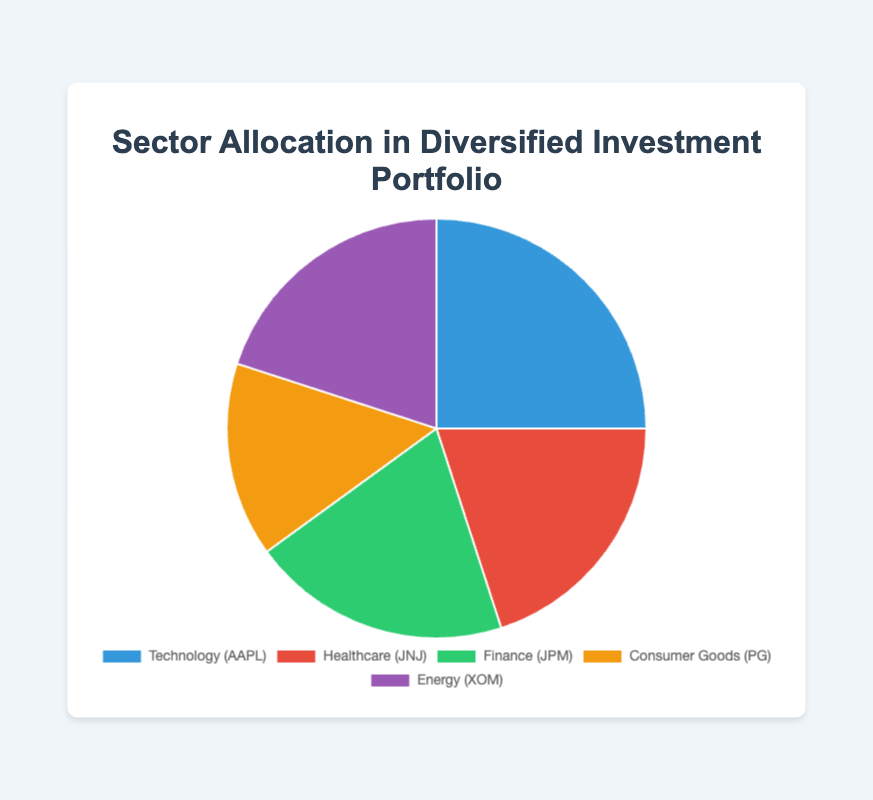What percentage of the portfolio is allocated to the Finance sector? The Finance sector, represented by JPMorgan Chase & Co. with the symbol JPM, has an allocation percentage listed in the data.
Answer: 20% Which sector has the smallest allocation in the portfolio? By comparing the allocation percentages, the Consumer Goods sector, represented by Procter & Gamble Co. with 15%, has the smallest allocation.
Answer: Consumer Goods What is the combined allocation percentage for the Technology and Healthcare sectors? The Technology sector (Apple Inc.) is allocated 25%, and the Healthcare sector (Johnson & Johnson) is allocated 20%. Summing these up gives 25% + 20% = 45%.
Answer: 45% How does the allocation to the Energy sector compare with the allocation to the Finance sector? Both the Energy sector (Exxon Mobil Corporation) and the Finance sector (JPMorgan Chase & Co.) have equal allocation percentages of 20%.
Answer: They are equal If the Consumer Goods sector's allocation is increased by 5%, what will the new visual distribution look like for this sector? Originally, the Consumer Goods sector (Procter & Gamble Co.) has 15%. Increasing it by 5% will result in a new allocation of 15% + 5% = 20%, making it equal to Finance, Healthcare, and Energy sectors.
Answer: 20% What is the total percentage allocated to non-Technology sectors? Adding the allocation percentages of Healthcare (20%), Finance (20%), Consumer Goods (15%), and Energy (20%) gives 20% + 20% + 15% + 20% = 75%.
Answer: 75% Which sector is represented with the color red in the pie chart? Examining the color-coding information, the Healthcare sector (Johnson & Johnson) is represented with the color red.
Answer: Healthcare In terms of portfolio diversification, how balanced is the allocation across different sectors? The allocation is moderately balanced. Although Technology has the highest allocation at 25%, the remaining sectors (Healthcare, Finance, Energy - 20% each, and Consumer Goods - 15%) are fairly close in their percentages.
Answer: Moderately balanced 